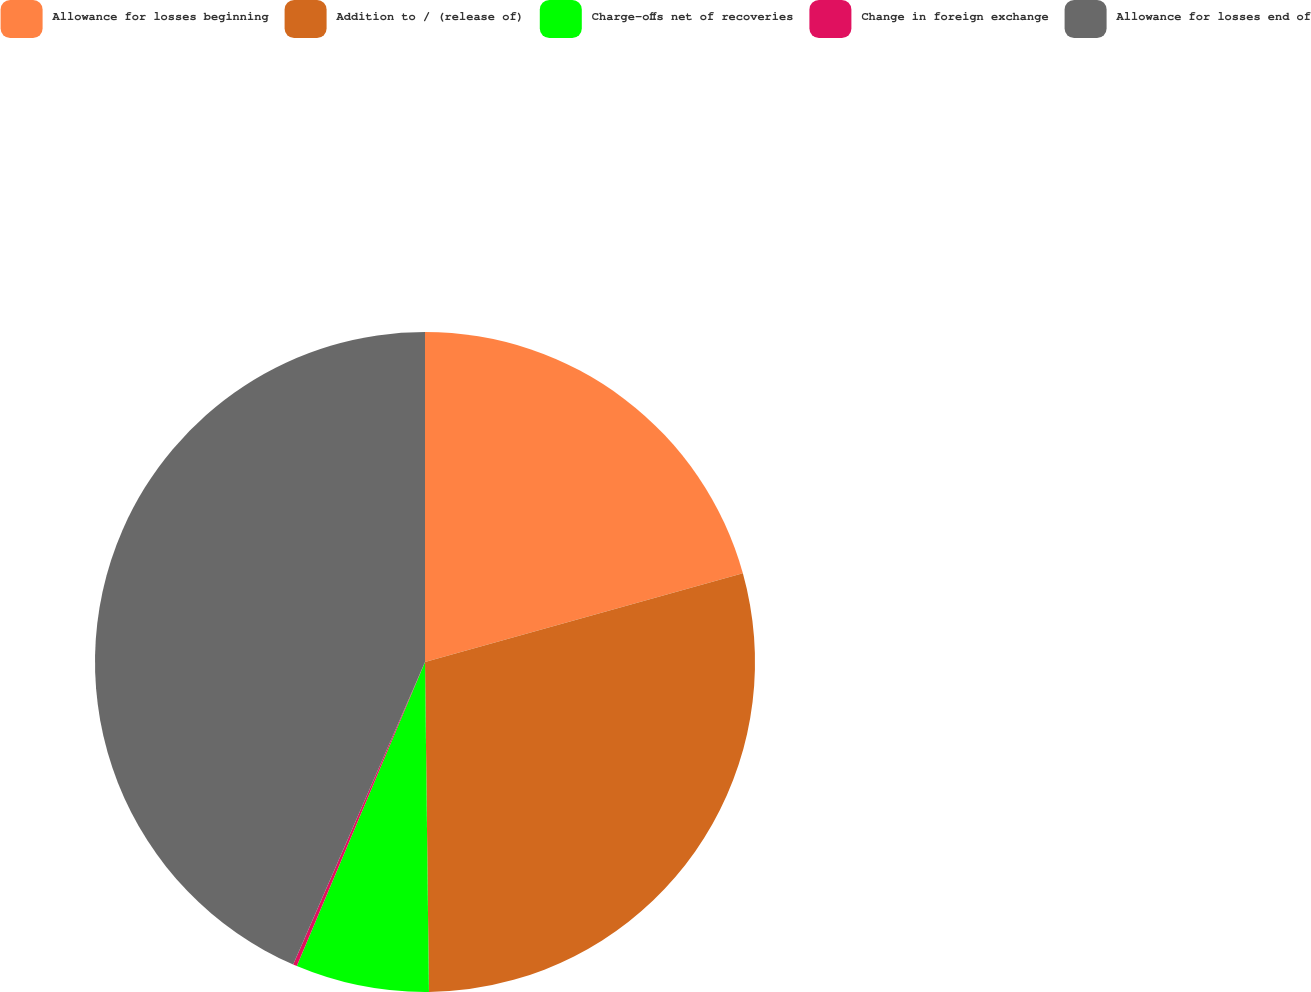Convert chart to OTSL. <chart><loc_0><loc_0><loc_500><loc_500><pie_chart><fcel>Allowance for losses beginning<fcel>Addition to / (release of)<fcel>Charge-offs net of recoveries<fcel>Change in foreign exchange<fcel>Allowance for losses end of<nl><fcel>20.67%<fcel>29.14%<fcel>6.54%<fcel>0.19%<fcel>43.46%<nl></chart> 